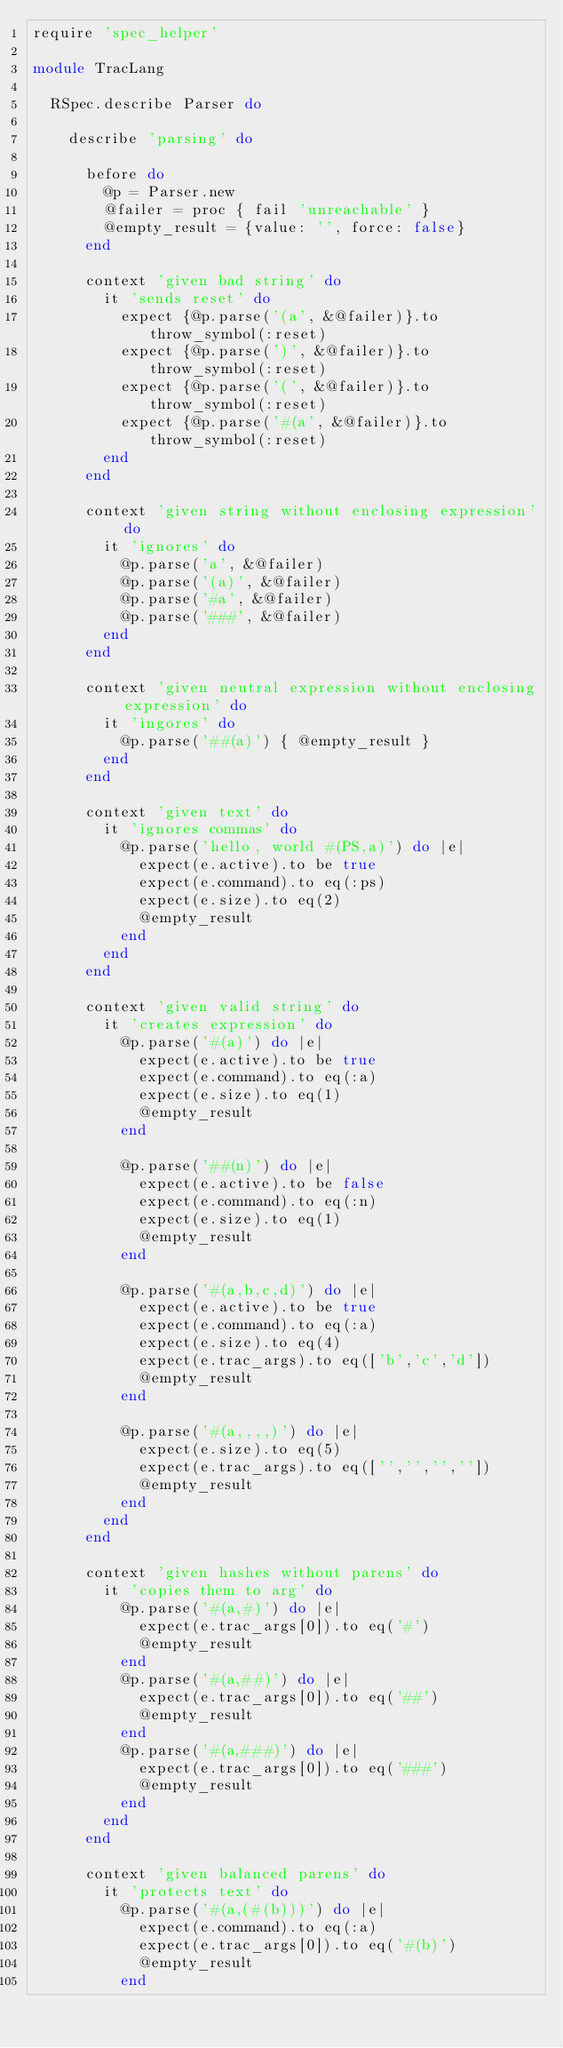<code> <loc_0><loc_0><loc_500><loc_500><_Ruby_>require 'spec_helper'

module TracLang 

  RSpec.describe Parser do

    describe 'parsing' do

      before do
        @p = Parser.new
        @failer = proc { fail 'unreachable' }
        @empty_result = {value: '', force: false}
      end
    
      context 'given bad string' do
        it 'sends reset' do
          expect {@p.parse('(a', &@failer)}.to throw_symbol(:reset)
          expect {@p.parse(')', &@failer)}.to throw_symbol(:reset)
          expect {@p.parse('(', &@failer)}.to throw_symbol(:reset)
          expect {@p.parse('#(a', &@failer)}.to throw_symbol(:reset)
        end
      end

      context 'given string without enclosing expression' do
        it 'ignores' do
          @p.parse('a', &@failer)
          @p.parse('(a)', &@failer)
          @p.parse('#a', &@failer)
          @p.parse('###', &@failer)
        end
      end
      
      context 'given neutral expression without enclosing expression' do
        it 'ingores' do
          @p.parse('##(a)') { @empty_result }
        end
      end
      
      context 'given text' do
        it 'ignores commas' do
          @p.parse('hello, world #(PS,a)') do |e|
            expect(e.active).to be true
            expect(e.command).to eq(:ps)
            expect(e.size).to eq(2)
            @empty_result
          end
        end
      end
      
      context 'given valid string' do
        it 'creates expression' do
          @p.parse('#(a)') do |e|
            expect(e.active).to be true
            expect(e.command).to eq(:a)
            expect(e.size).to eq(1)
            @empty_result
          end
          
          @p.parse('##(n)') do |e|
            expect(e.active).to be false
            expect(e.command).to eq(:n)
            expect(e.size).to eq(1)
            @empty_result
          end
          
          @p.parse('#(a,b,c,d)') do |e|
            expect(e.active).to be true
            expect(e.command).to eq(:a)
            expect(e.size).to eq(4)
            expect(e.trac_args).to eq(['b','c','d'])
            @empty_result
          end
          
          @p.parse('#(a,,,,)') do |e|
            expect(e.size).to eq(5)
            expect(e.trac_args).to eq(['','','',''])
            @empty_result
          end
        end
      end
      
      context 'given hashes without parens' do
        it 'copies them to arg' do
          @p.parse('#(a,#)') do |e|
            expect(e.trac_args[0]).to eq('#')
            @empty_result
          end
          @p.parse('#(a,##)') do |e|
            expect(e.trac_args[0]).to eq('##')
            @empty_result
          end
          @p.parse('#(a,###)') do |e|
            expect(e.trac_args[0]).to eq('###')
            @empty_result
          end
        end
      end
      
      context 'given balanced parens' do
        it 'protects text' do
          @p.parse('#(a,(#(b)))') do |e|
            expect(e.command).to eq(:a)
            expect(e.trac_args[0]).to eq('#(b)')
            @empty_result
          end</code> 